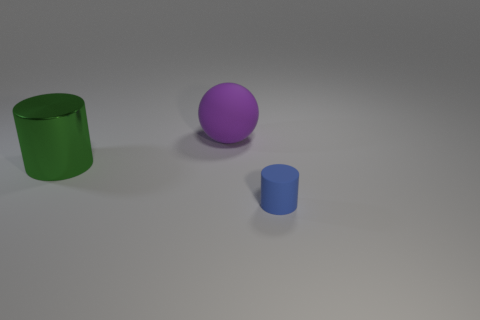What number of big things are both in front of the large purple thing and right of the big cylinder?
Your answer should be compact. 0. Are there any blue rubber cylinders left of the blue rubber object?
Your answer should be compact. No. There is a small blue rubber thing that is to the right of the large green cylinder; is its shape the same as the big object that is to the left of the large rubber sphere?
Keep it short and to the point. Yes. How many objects are big red spheres or things in front of the big purple ball?
Ensure brevity in your answer.  2. How many other things are there of the same shape as the purple object?
Keep it short and to the point. 0. Does the small object in front of the green shiny cylinder have the same material as the large sphere?
Make the answer very short. Yes. What number of objects are rubber spheres or blue things?
Give a very brief answer. 2. The blue object that is the same shape as the green metal thing is what size?
Ensure brevity in your answer.  Small. What is the size of the blue cylinder?
Your answer should be compact. Small. Are there more rubber things on the right side of the green metallic cylinder than big balls?
Provide a short and direct response. Yes. 